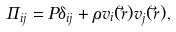Convert formula to latex. <formula><loc_0><loc_0><loc_500><loc_500>\Pi _ { i j } = P \delta _ { i j } + \rho v _ { i } ( \vec { r } ) v _ { j } ( \vec { r } ) ,</formula> 